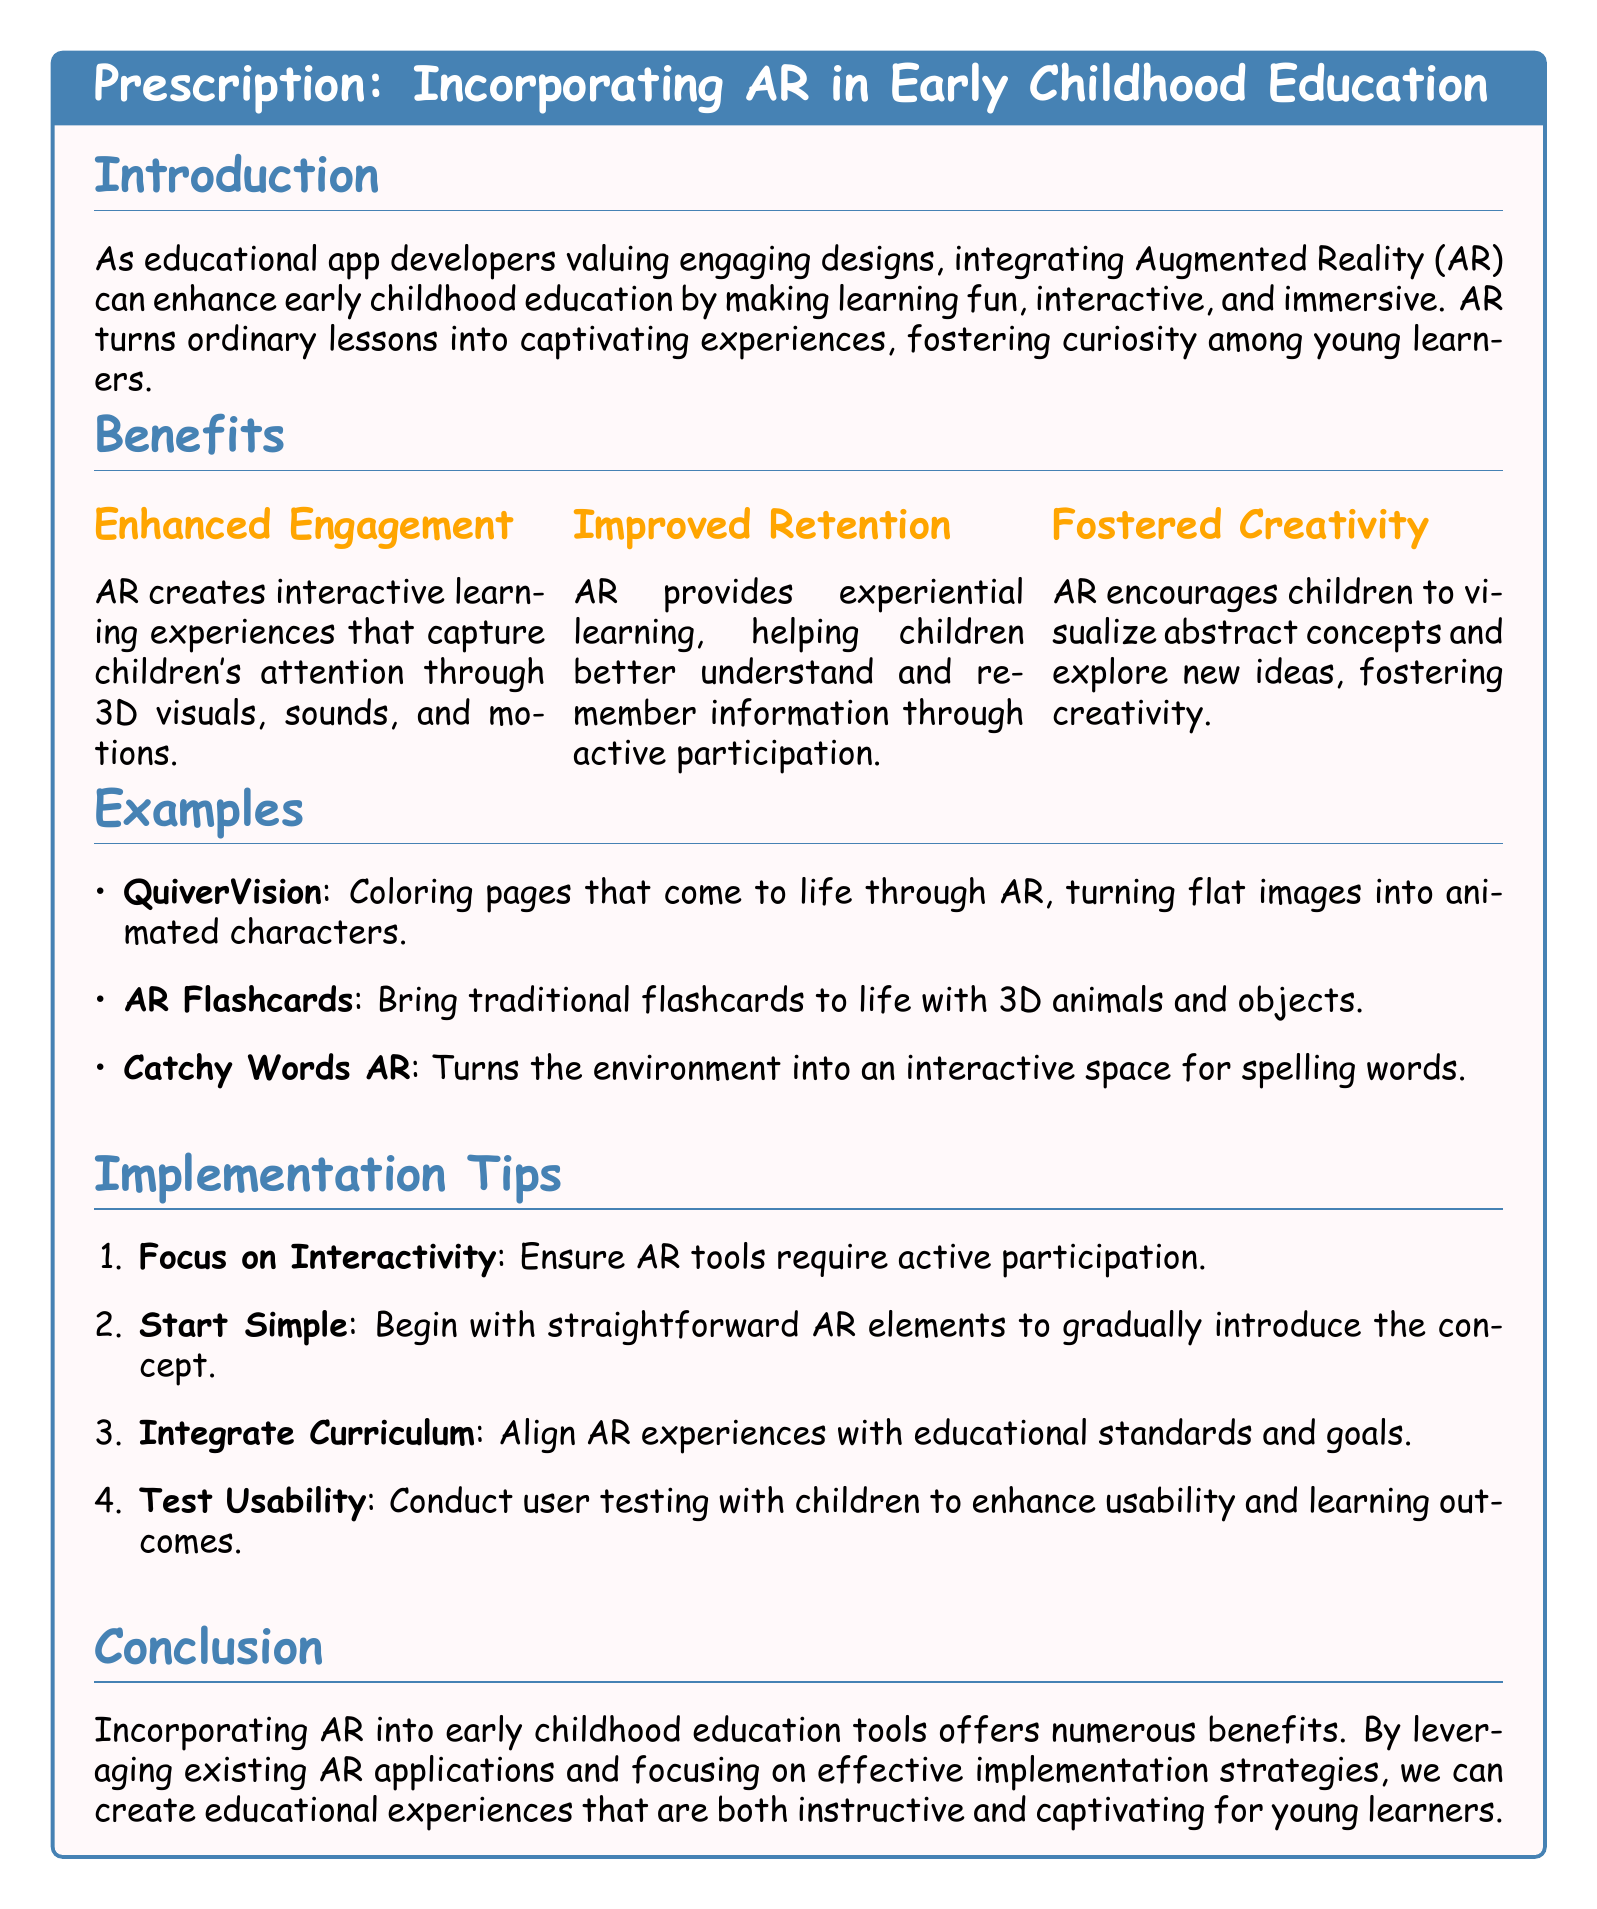What is the title of the document? The title can be found in the prescription box at the top of the document.
Answer: Incorporating AR in Early Childhood Education What color is used for the section titles? The color of the section titles is specified in the document formatting settings.
Answer: myblue Name one example of an AR application mentioned in the document. This information can be retrieved from the examples listed under the Examples section.
Answer: QuiverVision What is one benefit of incorporating AR according to the document? The benefits are enumerated in the Benefits section with clear points.
Answer: Enhanced Engagement How many implementation tips are provided? The total number of implementation tips can be counted in the Implementation Tips section.
Answer: Four What does the document suggest focusing on for AR tools? This detail is specified within the Implementation Tips section.
Answer: Interactivity Which font is used throughout the document? The main font for the document is defined at the beginning of the code.
Answer: Comic Sans MS What is the purpose of incorporating AR in education, as highlighted in the introduction? This purpose is summarized in the introductory text of the document.
Answer: Enhance early childhood education 